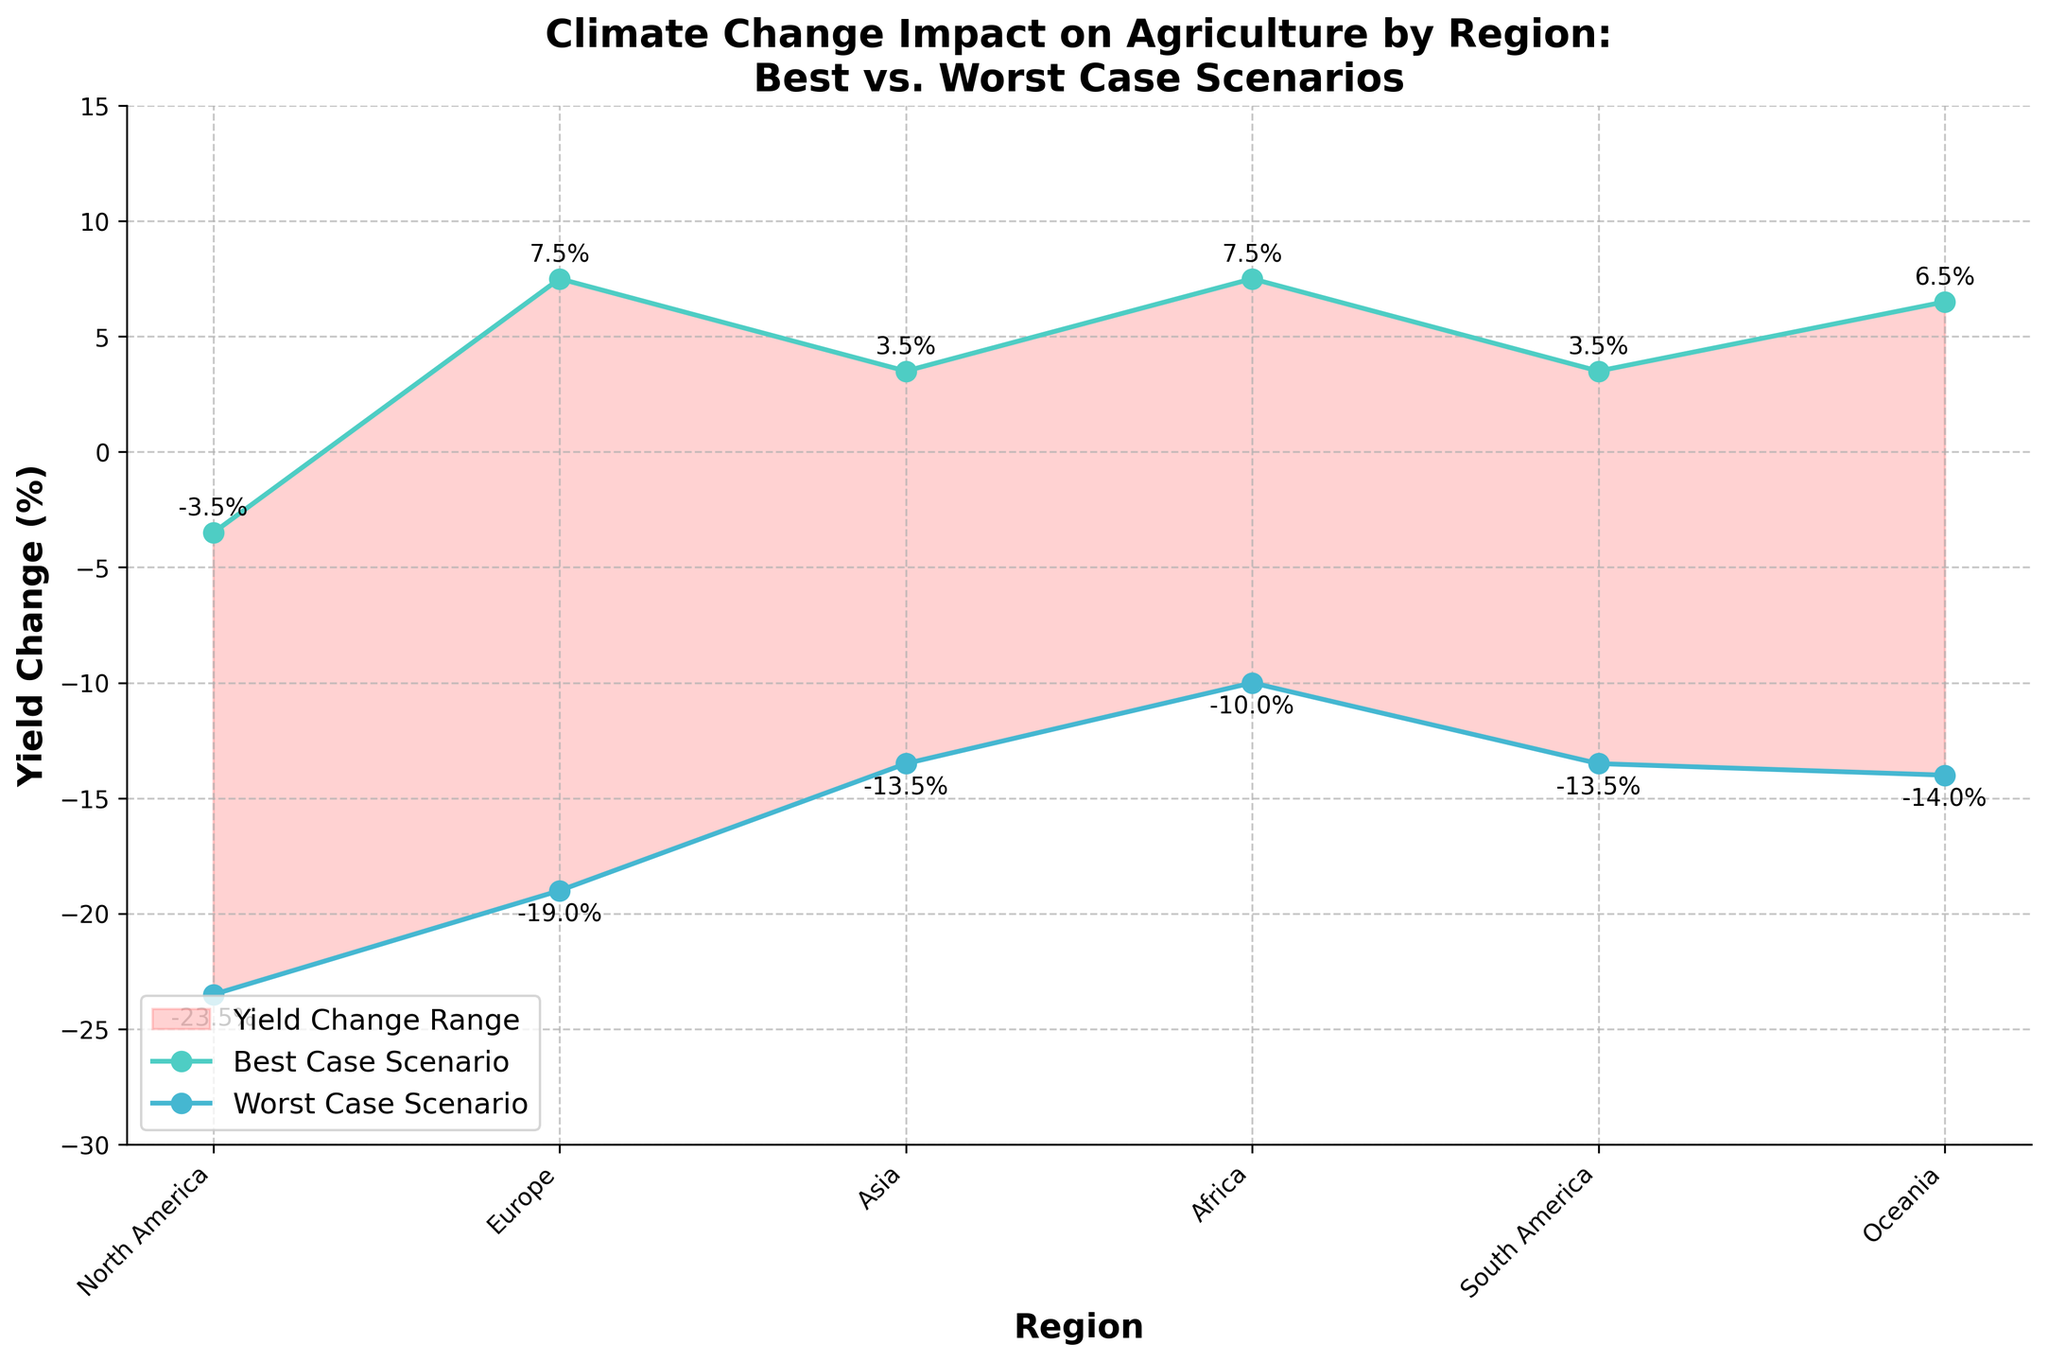What's the title of the chart? The title is usually located at the top of the chart. It provides an overview of what the chart is about.
Answer: Climate Change Impact on Agriculture by Region: Best vs. Worst Case Scenarios How many regions are compared in the chart? Count the number of unique regions along the x-axis. There are 6 regions listed along the x-axis: North America, Europe, Asia, Africa, South America, and Oceania.
Answer: 6 What is the best-case yield change percentage for North America? Identify the best-case scenario plot marked with teal colored markers. Then, look for the value corresponding to North America. The value is labeled near the North American marker.
Answer: 7.5% Which region has the worst-case yield change percentage below -20%? Look at the worst-case scenario plot marked with light blue markers. Any line segment going below -20% on the y-axis belongs to the regions to be identified. Africa (Kenya -25% and South Africa -22%) has the worst-case yield change below -20%.
Answer: Africa What is the difference between the best-case and worst-case yield change percentages for Europe? First, locate Europe's best-case percentage (between 3% and 4%) and worst-case percentage (between -14% and -13%). Now, calculate the difference: best-case 3.5% - worst-case -13.5% = 17%.
Answer: 17% Which region shows the smallest range of yield change between the best and worst case scenarios? The range of yield change can be determined by calculating the difference between the best-case and worst-case yield for each region and comparing them. The smallest range is found for Oceania (Australia and New Zealand): best-case 3.5% and worst-case -13.5%. Difference is 17%.
Answer: Oceania Which region has the highest best-case yield change percentage? Check the best-case scenario plot (teal colored markers) for each region and identify the highest value. Asia (India 8%) shows the highest best-case yield change.
Answer: Asia How is the yield change trend in South America compared to Africa? Compare the best-case and worst-case yield change markers for both South America and Africa. South America shows positive yield changes (around -1% to -15%) with less drastic worst-case scenarios compared to Africa (negative showing below -20%).
Answer: South America exhibits relatively smaller yield reductions compared to Africa 